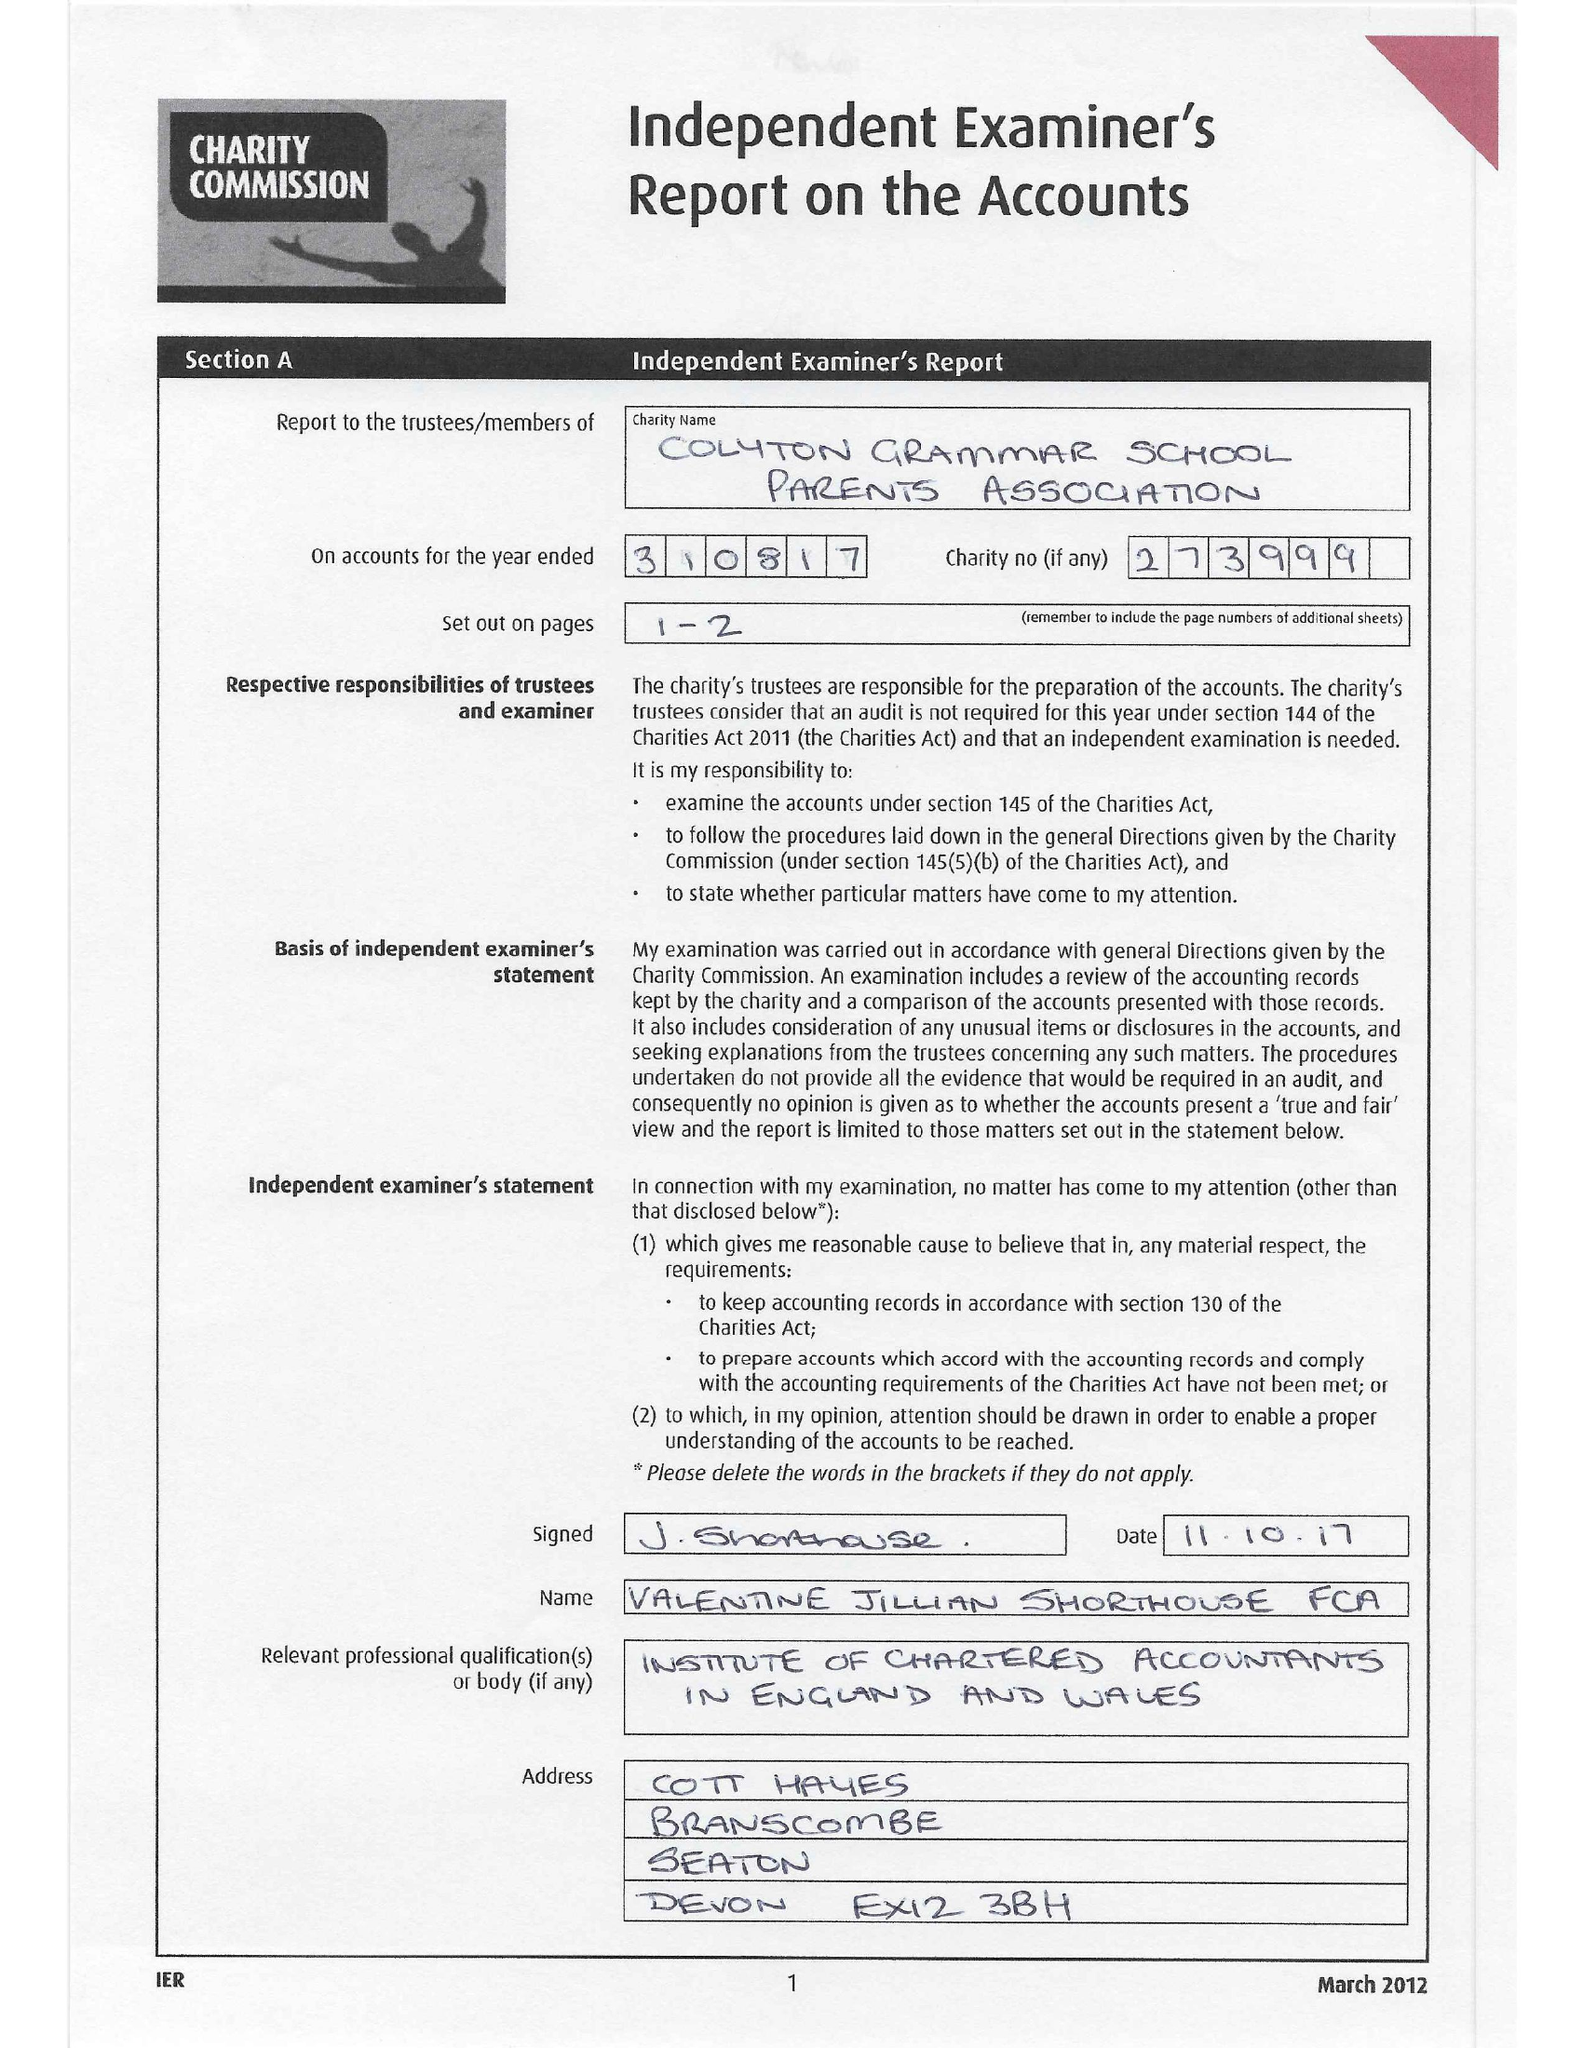What is the value for the report_date?
Answer the question using a single word or phrase. 2017-08-31 